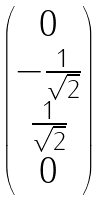<formula> <loc_0><loc_0><loc_500><loc_500>\begin{pmatrix} 0 \\ - \frac { 1 } { \sqrt { 2 } } \\ \frac { 1 } { \sqrt { 2 } } \\ 0 \end{pmatrix}</formula> 